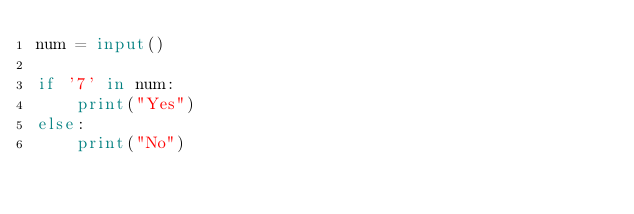<code> <loc_0><loc_0><loc_500><loc_500><_Python_>num = input()
  
if '7' in num:
    print("Yes")
else:
    print("No")</code> 